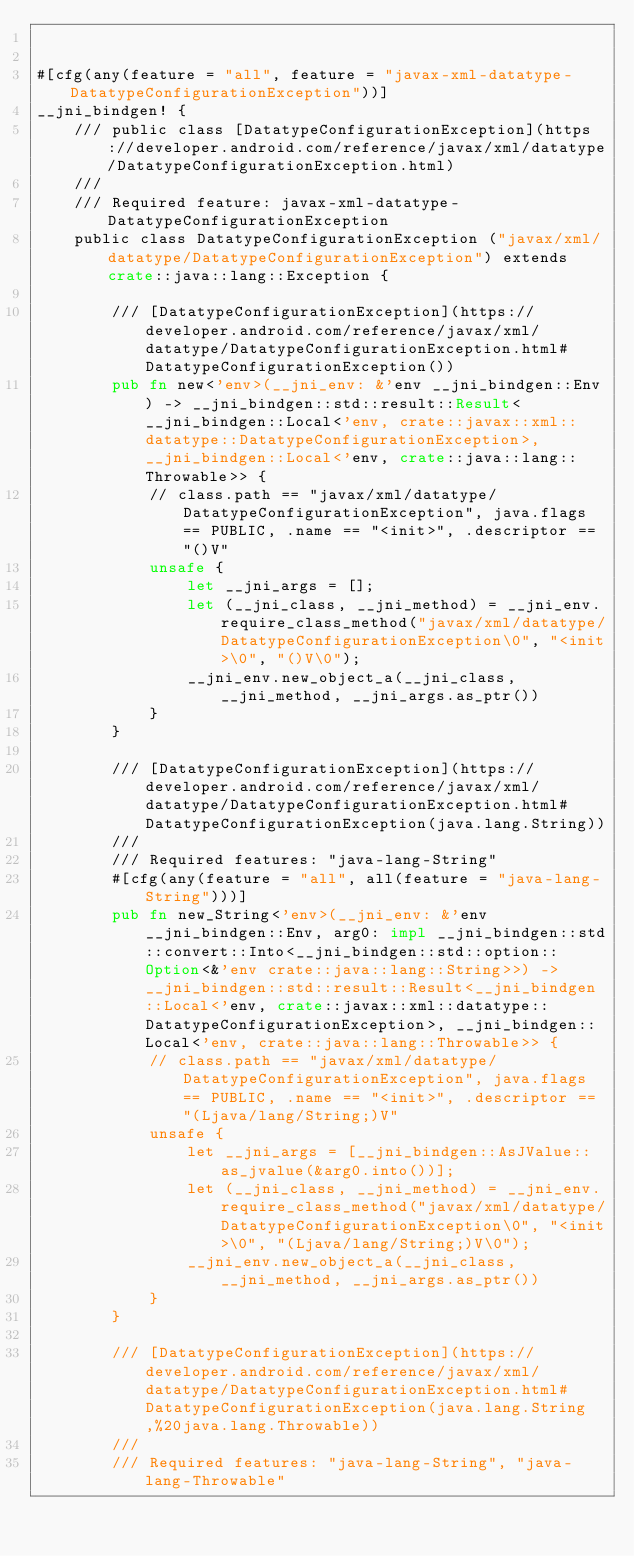<code> <loc_0><loc_0><loc_500><loc_500><_Rust_>

#[cfg(any(feature = "all", feature = "javax-xml-datatype-DatatypeConfigurationException"))]
__jni_bindgen! {
    /// public class [DatatypeConfigurationException](https://developer.android.com/reference/javax/xml/datatype/DatatypeConfigurationException.html)
    ///
    /// Required feature: javax-xml-datatype-DatatypeConfigurationException
    public class DatatypeConfigurationException ("javax/xml/datatype/DatatypeConfigurationException") extends crate::java::lang::Exception {

        /// [DatatypeConfigurationException](https://developer.android.com/reference/javax/xml/datatype/DatatypeConfigurationException.html#DatatypeConfigurationException())
        pub fn new<'env>(__jni_env: &'env __jni_bindgen::Env) -> __jni_bindgen::std::result::Result<__jni_bindgen::Local<'env, crate::javax::xml::datatype::DatatypeConfigurationException>, __jni_bindgen::Local<'env, crate::java::lang::Throwable>> {
            // class.path == "javax/xml/datatype/DatatypeConfigurationException", java.flags == PUBLIC, .name == "<init>", .descriptor == "()V"
            unsafe {
                let __jni_args = [];
                let (__jni_class, __jni_method) = __jni_env.require_class_method("javax/xml/datatype/DatatypeConfigurationException\0", "<init>\0", "()V\0");
                __jni_env.new_object_a(__jni_class, __jni_method, __jni_args.as_ptr())
            }
        }

        /// [DatatypeConfigurationException](https://developer.android.com/reference/javax/xml/datatype/DatatypeConfigurationException.html#DatatypeConfigurationException(java.lang.String))
        ///
        /// Required features: "java-lang-String"
        #[cfg(any(feature = "all", all(feature = "java-lang-String")))]
        pub fn new_String<'env>(__jni_env: &'env __jni_bindgen::Env, arg0: impl __jni_bindgen::std::convert::Into<__jni_bindgen::std::option::Option<&'env crate::java::lang::String>>) -> __jni_bindgen::std::result::Result<__jni_bindgen::Local<'env, crate::javax::xml::datatype::DatatypeConfigurationException>, __jni_bindgen::Local<'env, crate::java::lang::Throwable>> {
            // class.path == "javax/xml/datatype/DatatypeConfigurationException", java.flags == PUBLIC, .name == "<init>", .descriptor == "(Ljava/lang/String;)V"
            unsafe {
                let __jni_args = [__jni_bindgen::AsJValue::as_jvalue(&arg0.into())];
                let (__jni_class, __jni_method) = __jni_env.require_class_method("javax/xml/datatype/DatatypeConfigurationException\0", "<init>\0", "(Ljava/lang/String;)V\0");
                __jni_env.new_object_a(__jni_class, __jni_method, __jni_args.as_ptr())
            }
        }

        /// [DatatypeConfigurationException](https://developer.android.com/reference/javax/xml/datatype/DatatypeConfigurationException.html#DatatypeConfigurationException(java.lang.String,%20java.lang.Throwable))
        ///
        /// Required features: "java-lang-String", "java-lang-Throwable"</code> 